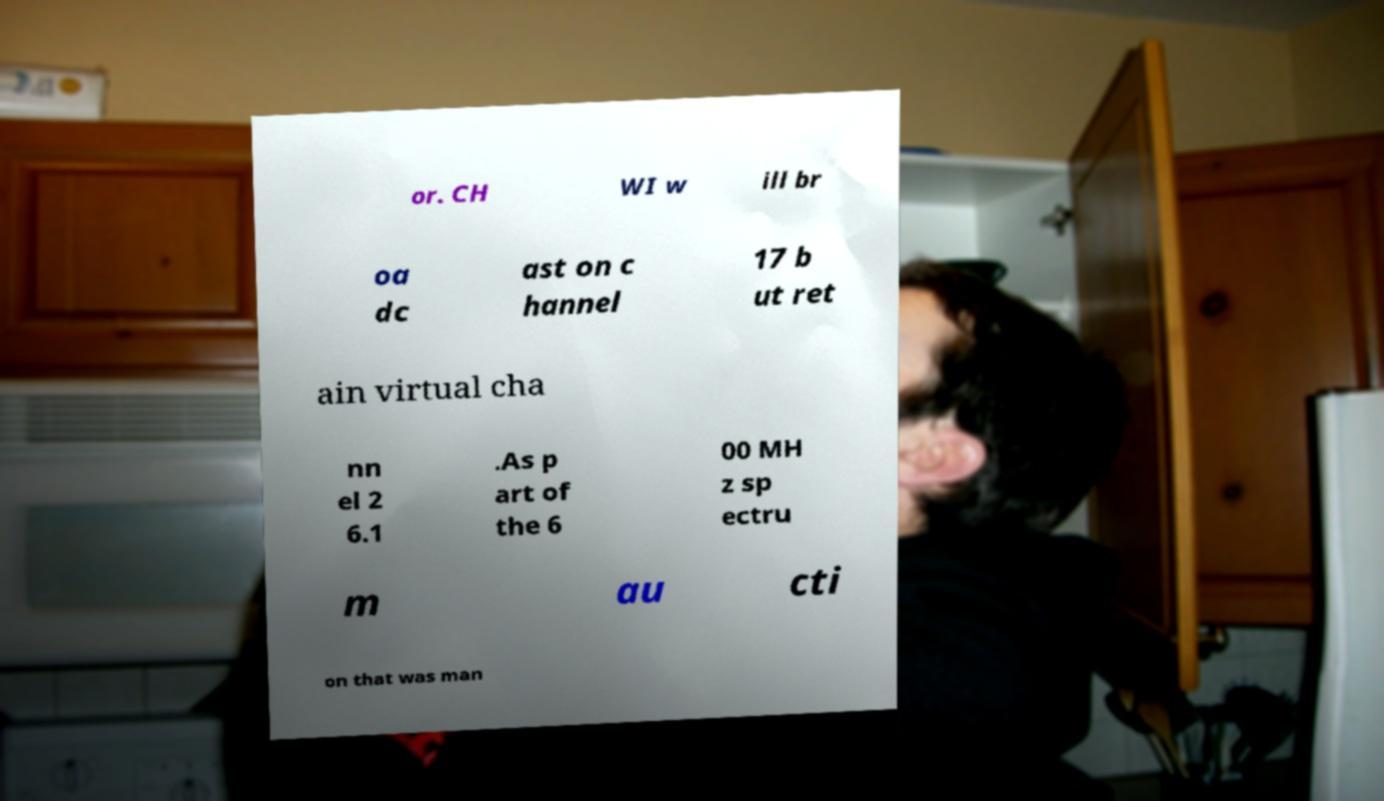Please read and relay the text visible in this image. What does it say? or. CH WI w ill br oa dc ast on c hannel 17 b ut ret ain virtual cha nn el 2 6.1 .As p art of the 6 00 MH z sp ectru m au cti on that was man 